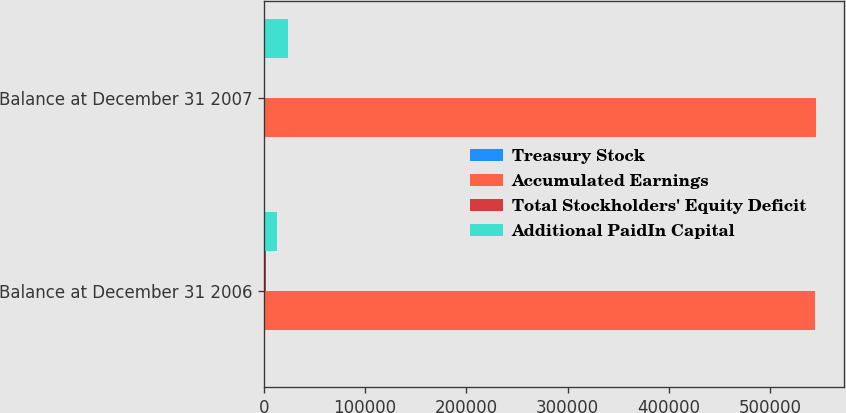Convert chart. <chart><loc_0><loc_0><loc_500><loc_500><stacked_bar_chart><ecel><fcel>Balance at December 31 2006<fcel>Balance at December 31 2007<nl><fcel>Treasury Stock<fcel>78<fcel>78<nl><fcel>Accumulated Earnings<fcel>544686<fcel>545654<nl><fcel>Total Stockholders' Equity Deficit<fcel>2208<fcel>386<nl><fcel>Additional PaidIn Capital<fcel>13097<fcel>23641<nl></chart> 